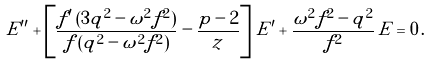Convert formula to latex. <formula><loc_0><loc_0><loc_500><loc_500>E ^ { \prime \prime } + \left [ \frac { f ^ { \prime } \, ( 3 q ^ { 2 } - \omega ^ { 2 } f ^ { 2 } ) } { f \, ( q ^ { 2 } - \omega ^ { 2 } f ^ { 2 } ) } - \frac { p - 2 } { z } \right ] \, E ^ { \prime } + \frac { \omega ^ { 2 } f ^ { 2 } - q ^ { 2 } } { f ^ { 2 } } \, E = 0 \, .</formula> 